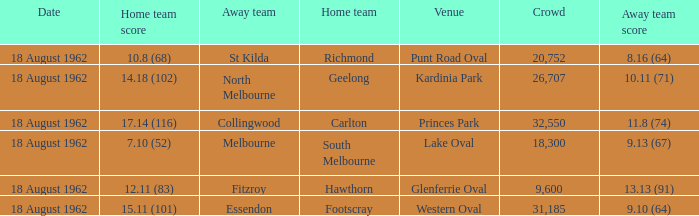What was the home team that scored 10.8 (68)? Richmond. 